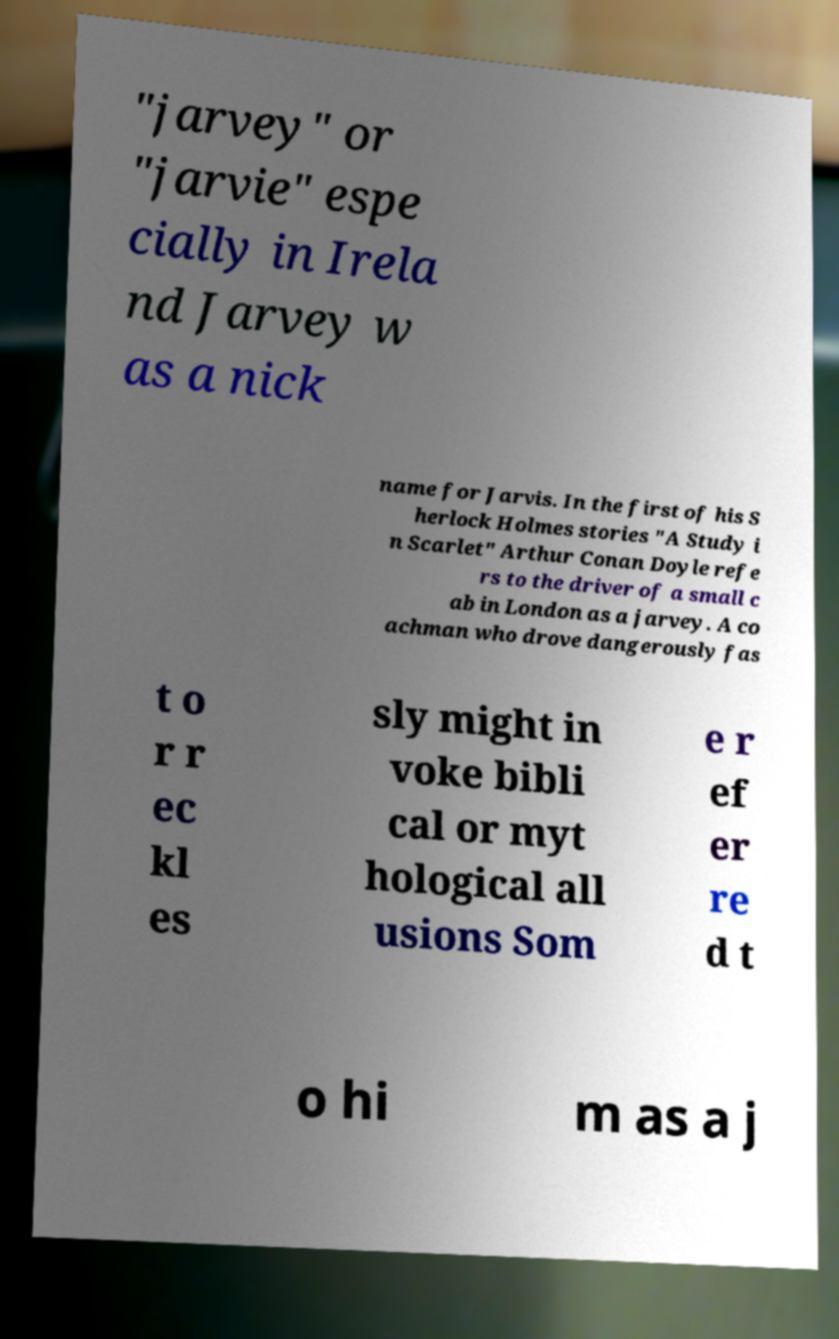Could you assist in decoding the text presented in this image and type it out clearly? "jarvey" or "jarvie" espe cially in Irela nd Jarvey w as a nick name for Jarvis. In the first of his S herlock Holmes stories "A Study i n Scarlet" Arthur Conan Doyle refe rs to the driver of a small c ab in London as a jarvey. A co achman who drove dangerously fas t o r r ec kl es sly might in voke bibli cal or myt hological all usions Som e r ef er re d t o hi m as a j 